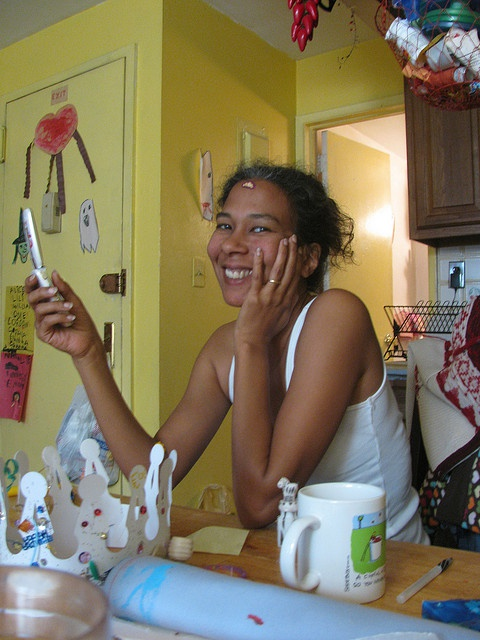Describe the objects in this image and their specific colors. I can see people in olive, gray, brown, and maroon tones, dining table in olive and gray tones, cup in olive, lightblue, darkgray, and gray tones, and cell phone in olive, lightgray, darkgray, and gray tones in this image. 